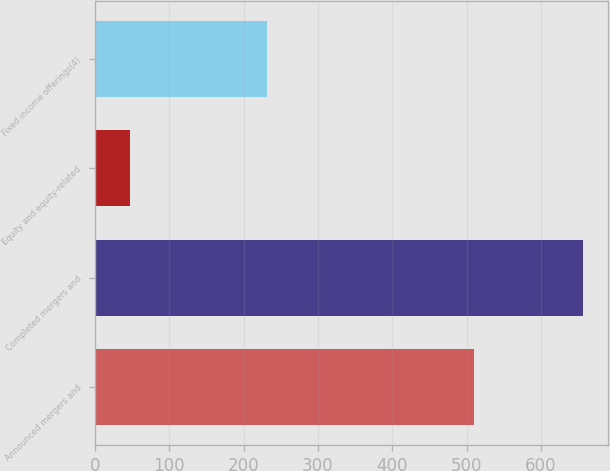<chart> <loc_0><loc_0><loc_500><loc_500><bar_chart><fcel>Announced mergers and<fcel>Completed mergers and<fcel>Equity and equity-related<fcel>Fixed income offerings(4)<nl><fcel>510<fcel>657<fcel>47<fcel>231<nl></chart> 